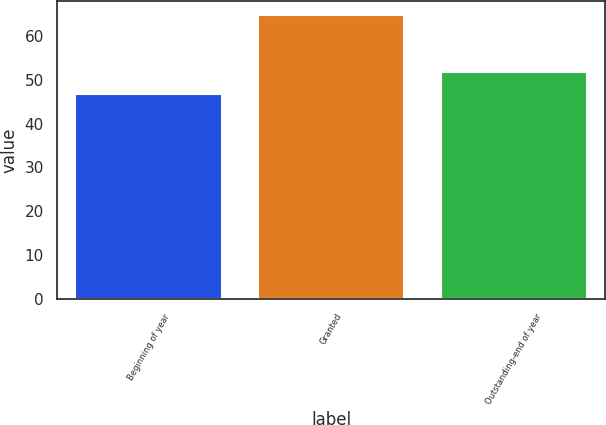<chart> <loc_0><loc_0><loc_500><loc_500><bar_chart><fcel>Beginning of year<fcel>Granted<fcel>Outstanding-end of year<nl><fcel>46.63<fcel>64.74<fcel>51.73<nl></chart> 